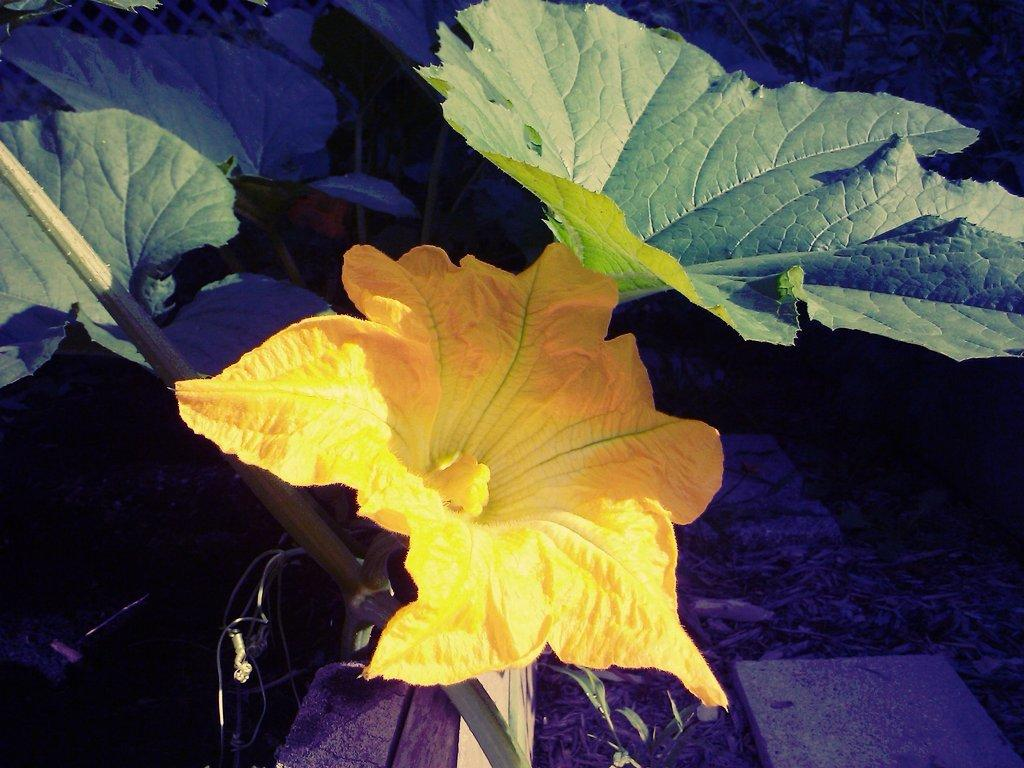What is the main subject of the image? There is a yellow flower in the middle of the image. What color are the leaves in the image? There are green leaves in the image. How does the flower account for its afterthought in the image? There is no indication in the image that the flower has an afterthought or is capable of accounting for one. 